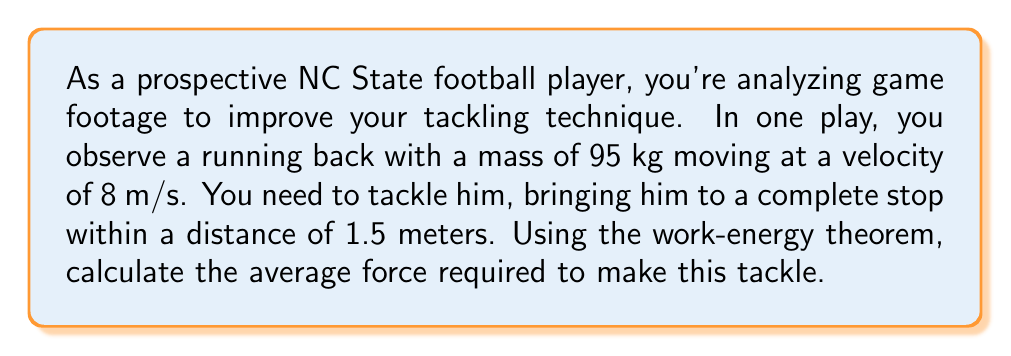Show me your answer to this math problem. Let's approach this step-by-step using the work-energy theorem:

1) The work-energy theorem states that the work done on an object is equal to its change in kinetic energy:
   $$W = \Delta KE$$

2) Work is also defined as force times distance:
   $$W = F \cdot d$$

3) Kinetic energy is given by the formula:
   $$KE = \frac{1}{2}mv^2$$

4) The change in kinetic energy is the final KE minus the initial KE:
   $$\Delta KE = KE_f - KE_i = 0 - \frac{1}{2}mv^2$$
   (Final KE is 0 because the player is brought to a stop)

5) Substituting these into the work-energy theorem:
   $$F \cdot d = -\frac{1}{2}mv^2$$

6) Solving for F:
   $$F = -\frac{mv^2}{2d}$$

7) Now, let's plug in our values:
   $m = 95$ kg
   $v = 8$ m/s
   $d = 1.5$ m

   $$F = -\frac{95 \cdot 8^2}{2 \cdot 1.5} = -2026.67$$

8) The negative sign indicates the direction of the force (opposite to the motion), but we're interested in the magnitude:

   $$|F| = 2026.67 \text{ N}$$

Therefore, the average force required to tackle the running back is approximately 2027 N.
Answer: 2027 N 